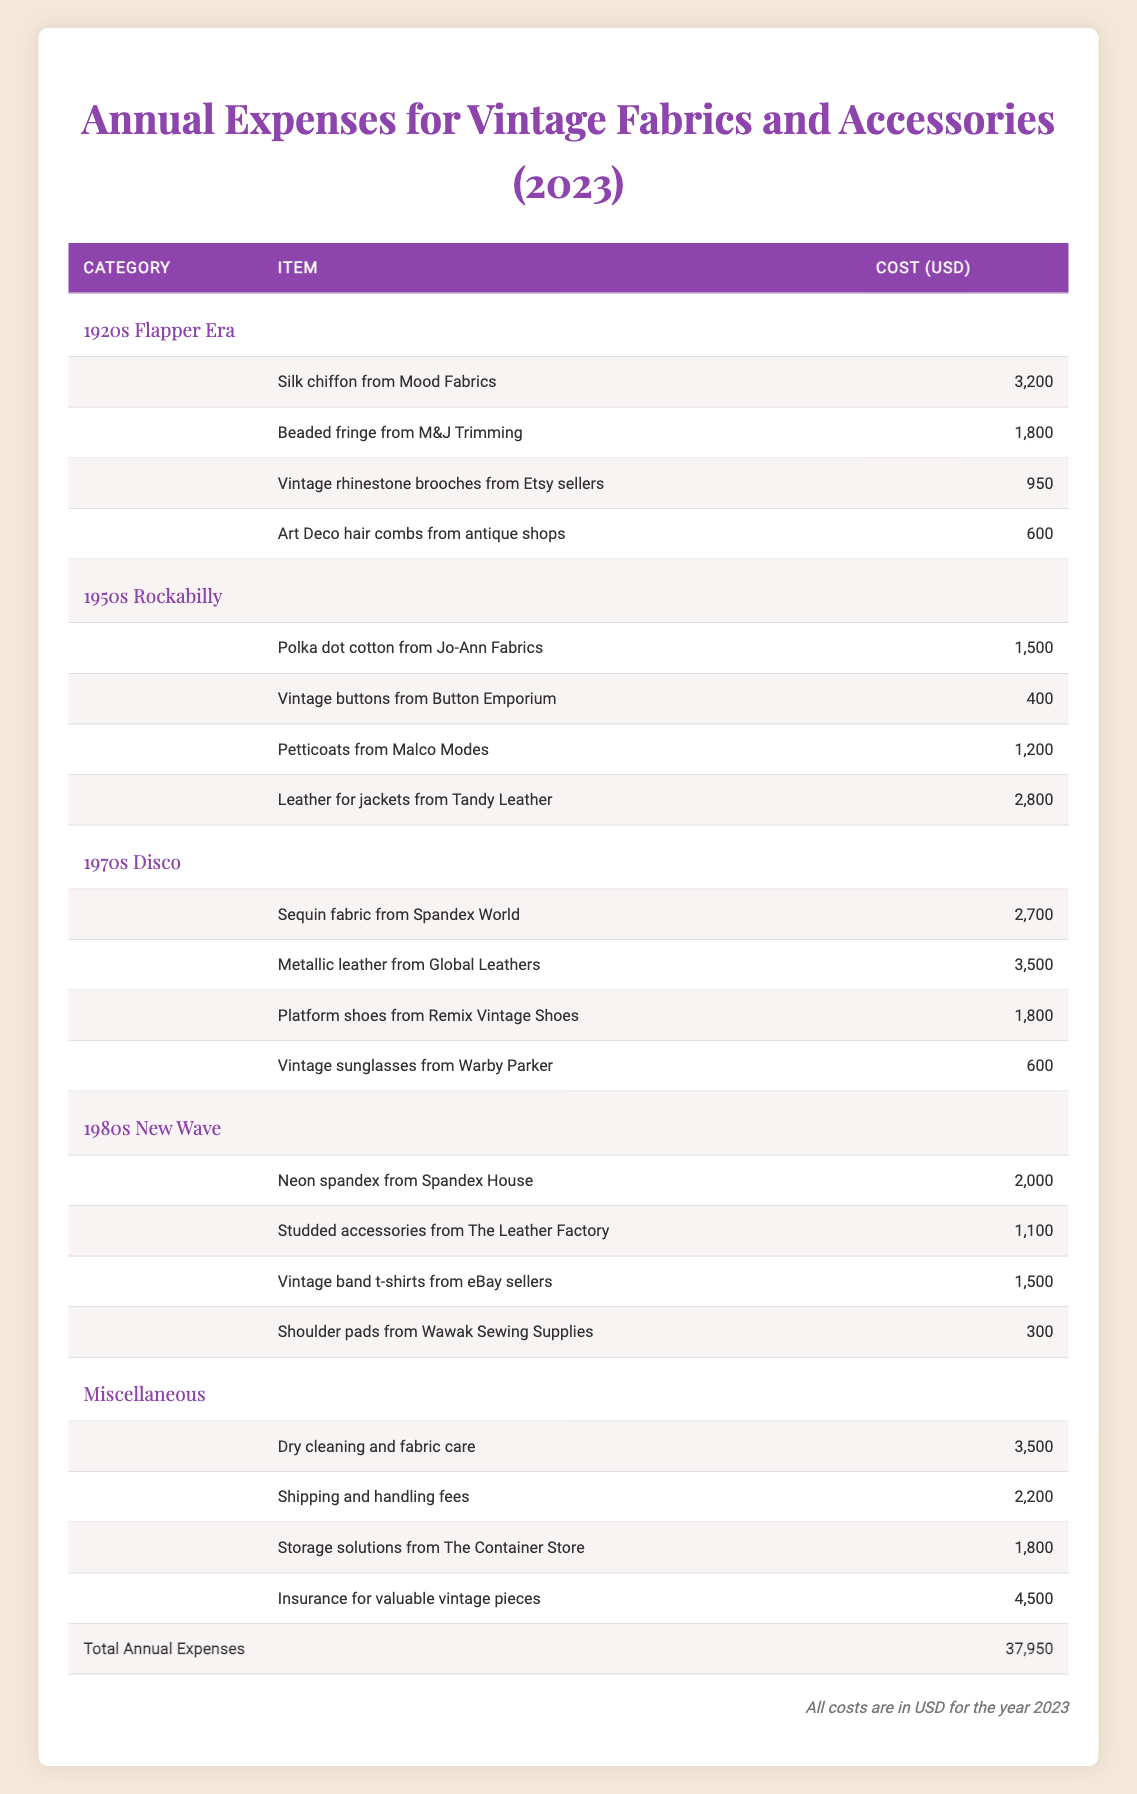What is the total annual expense for sourcing vintage fabrics and accessories? The total annual expenses are listed at the bottom of the table, which shows a sum of 37,950 USD for the year 2023.
Answer: 37,950 USD Which category has the highest expense? The 1970s Disco category has the highest individual expense, with a total of 8,600 USD derived from summing its items: 2,700 (sequin fabric) + 3,500 (metallic leather) + 1,800 (platform shoes) + 600 (vintage sunglasses).
Answer: 1970s Disco How much was spent on cleaning and fabric care in the miscellaneous category? Referring to the miscellaneous section, the expense for dry cleaning and fabric care is explicitly listed as 3,500 USD.
Answer: 3,500 USD Is the total cost spent on vintage buttons greater than the cost for vintage rhinestone brooches? The cost for vintage buttons is 400 USD, and for vintage rhinestone brooches, it is 950 USD. Since 400 USD is less than 950 USD, the answer is no.
Answer: No What is the average cost of items in the 1980s New Wave category? The total cost for the 1980s New Wave category is 4,900 USD (2,000 + 1,100 + 1,500 + 300), and there are four items. Thus, the average cost is 4,900 / 4 = 1,225 USD.
Answer: 1,225 USD If the cost for leather jackets in the 1950s Rockabilly category was removed, what would the new total annual expense be? The cost for leather jackets is 2,800 USD. By subtracting this from the original total of 37,950 USD, the new total would be 37,950 - 2,800 = 35,150 USD.
Answer: 35,150 USD Are there any items listed under the 1920s Flapper Era category that cost more than those in the 1980s New Wave category? The highest cost in the 1920s Flapper Era is 3,200 USD (silk chiffon), while the highest cost in the 1980s New Wave is 2,000 USD. Since 3,200 USD is greater than 2,000 USD, the answer is yes.
Answer: Yes How much was spent on vintage sunglasses compared to the total expenses for vintage fabrics in the 1970s Disco category? Vintage sunglasses cost 600 USD. The total spent for the 1970s Disco category is 8,600 USD. Since 600 USD is less than 8,600 USD, the answer is that it was much less.
Answer: Much less What is the cost of petticoats from Malco Modes? The expense for petticoats from Malco Modes is specified as 1,200 USD in the 1950s Rockabilly category.
Answer: 1,200 USD 